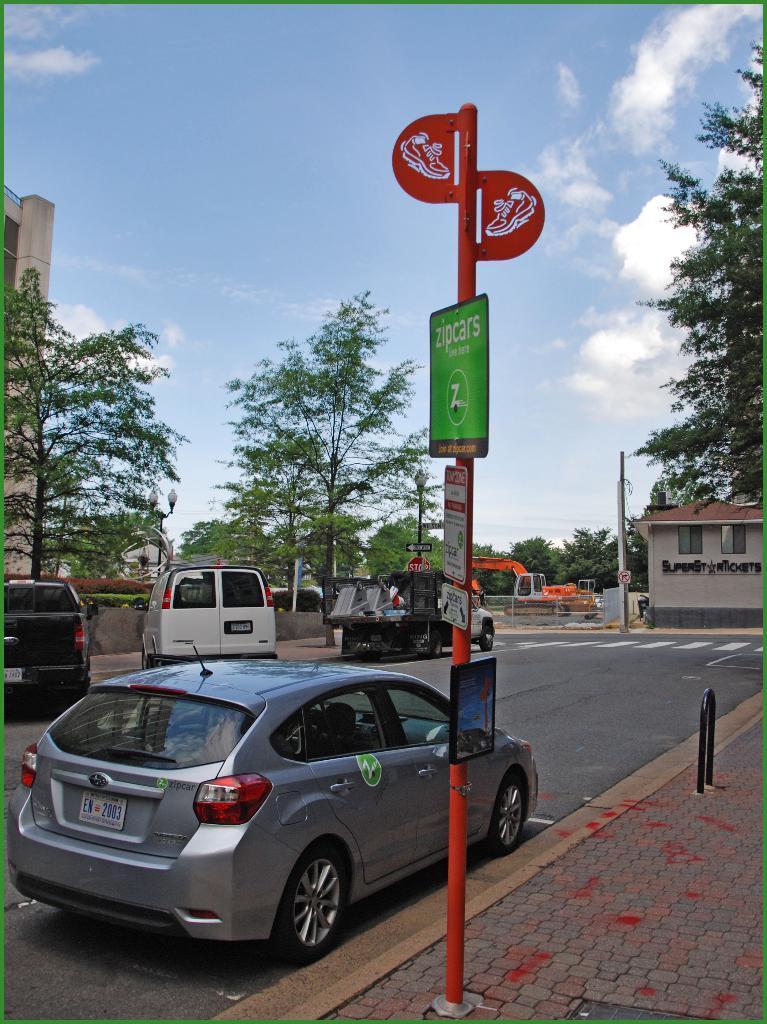Can you describe this image briefly? In this picture we can see a few vehicles on the road. We can see some boards on the pole. We can see a stand on the path in the bottom right. There are a few trees, vehicle and a house is visible on the right side. Sky is blue in color and cloudy. 